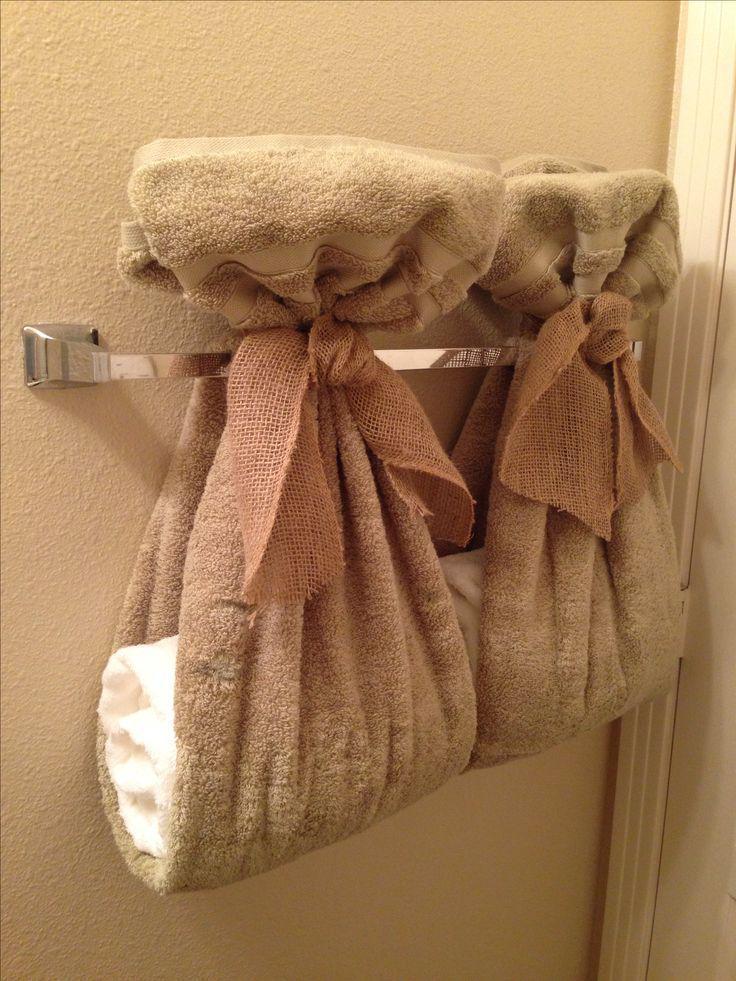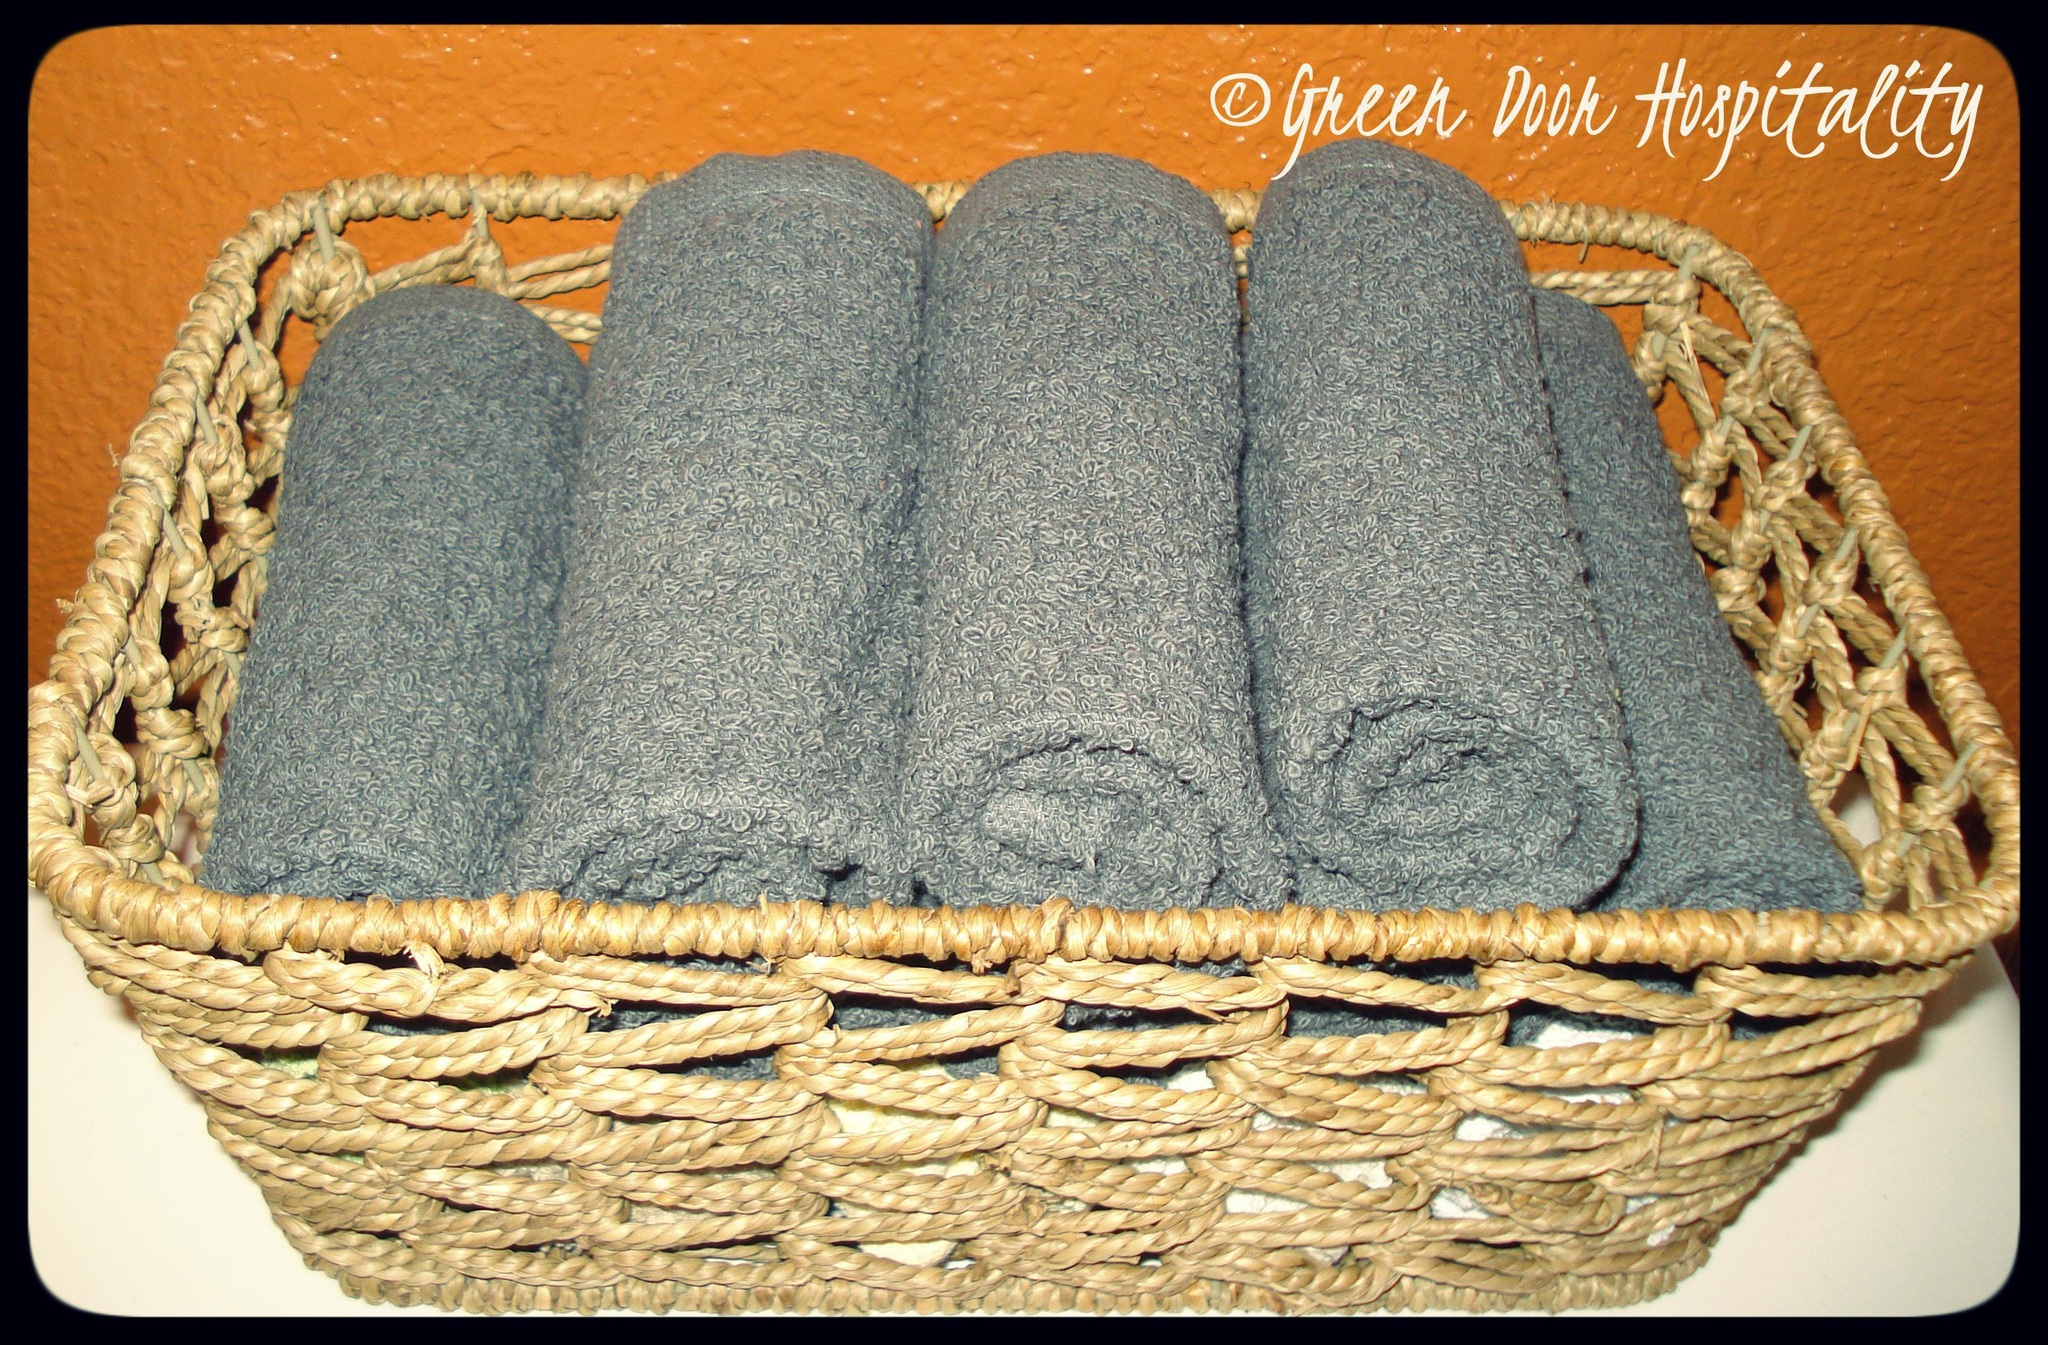The first image is the image on the left, the second image is the image on the right. Examine the images to the left and right. Is the description "The towels in the right image are not displayed in a basket-type container." accurate? Answer yes or no. No. The first image is the image on the left, the second image is the image on the right. Analyze the images presented: Is the assertion "There is a basket in the image on the left." valid? Answer yes or no. No. 